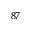Convert formula to latex. <formula><loc_0><loc_0><loc_500><loc_500>^ { 8 7 }</formula> 